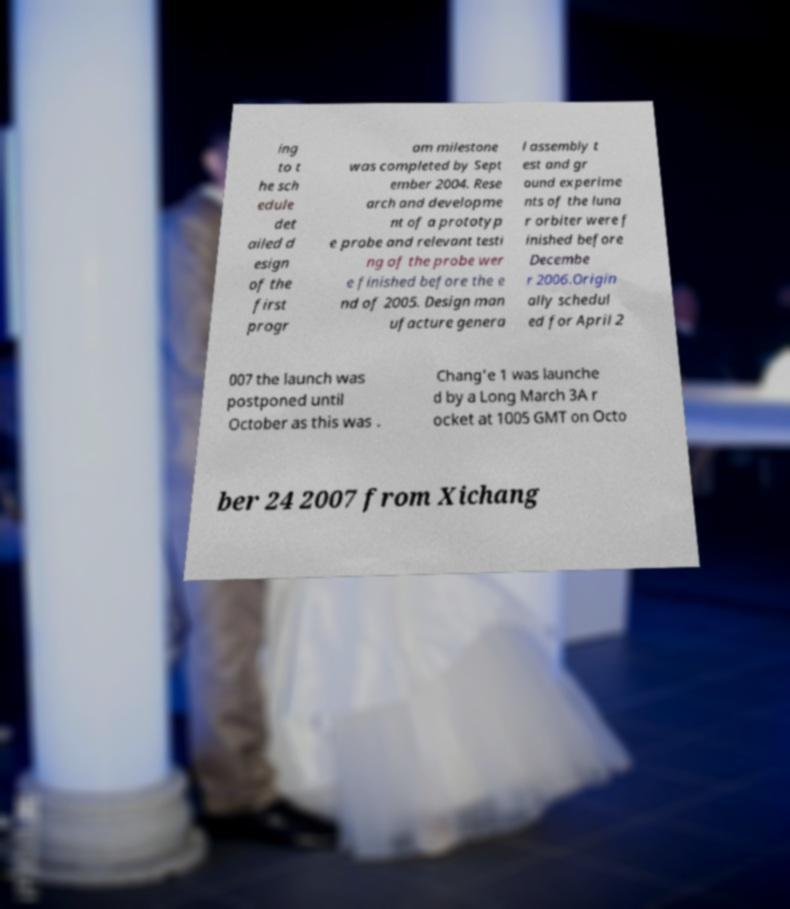Please read and relay the text visible in this image. What does it say? ing to t he sch edule det ailed d esign of the first progr am milestone was completed by Sept ember 2004. Rese arch and developme nt of a prototyp e probe and relevant testi ng of the probe wer e finished before the e nd of 2005. Design man ufacture genera l assembly t est and gr ound experime nts of the luna r orbiter were f inished before Decembe r 2006.Origin ally schedul ed for April 2 007 the launch was postponed until October as this was . Chang'e 1 was launche d by a Long March 3A r ocket at 1005 GMT on Octo ber 24 2007 from Xichang 